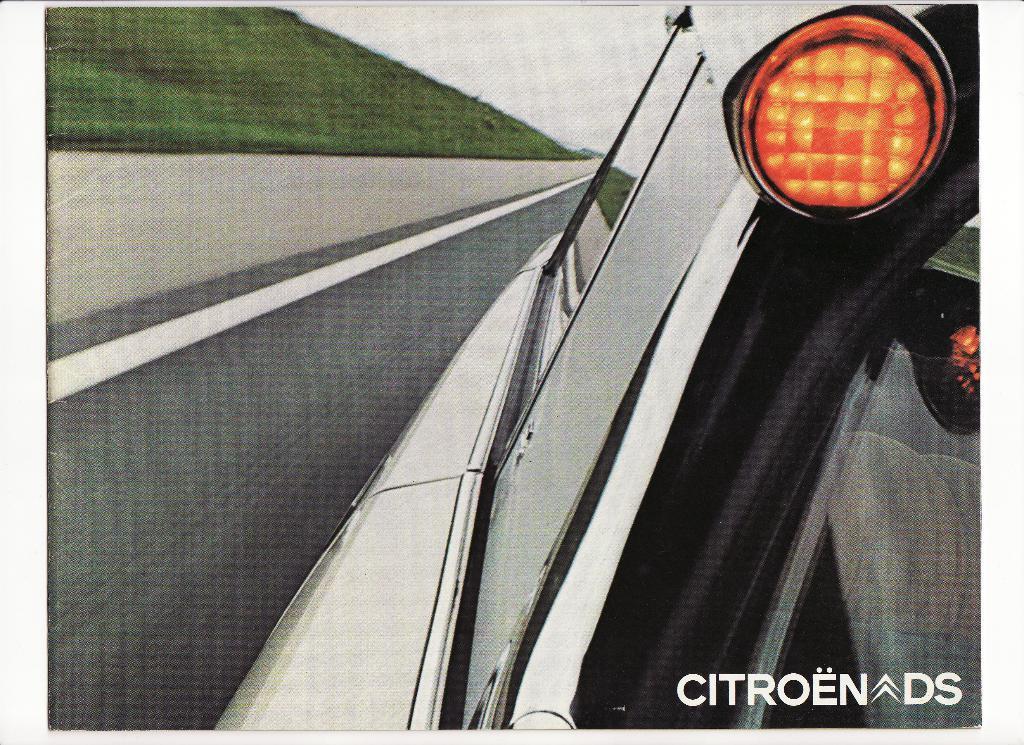Please provide a concise description of this image. This is an edited picture. I can see a vehicle on the road. I can see grass, and in the background there is the sky and there is a watermark on the image. 